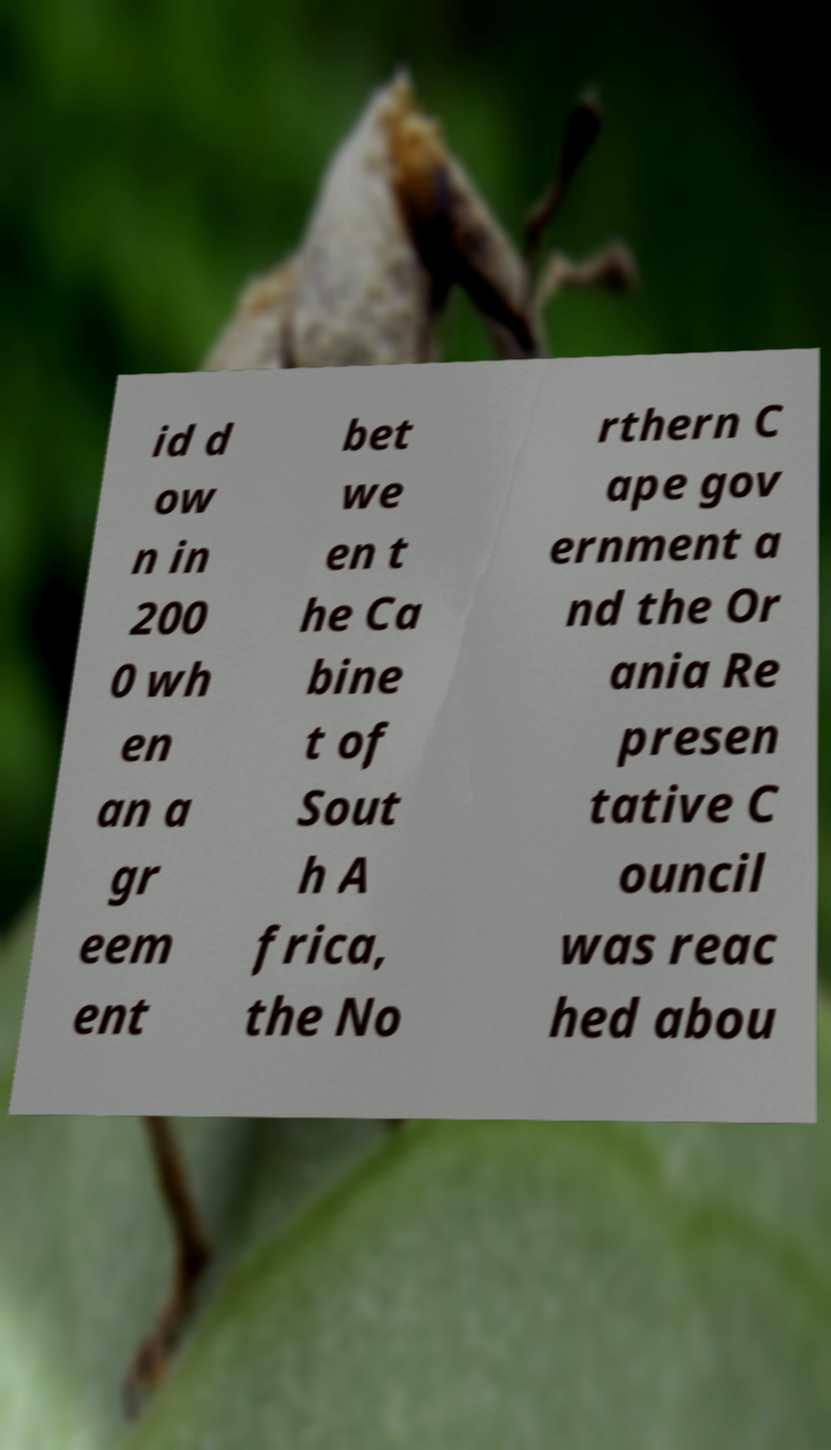There's text embedded in this image that I need extracted. Can you transcribe it verbatim? id d ow n in 200 0 wh en an a gr eem ent bet we en t he Ca bine t of Sout h A frica, the No rthern C ape gov ernment a nd the Or ania Re presen tative C ouncil was reac hed abou 